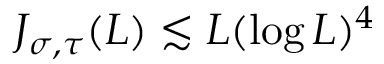<formula> <loc_0><loc_0><loc_500><loc_500>J _ { \sigma , \tau } ( L ) \lesssim L ( \log L ) ^ { 4 }</formula> 